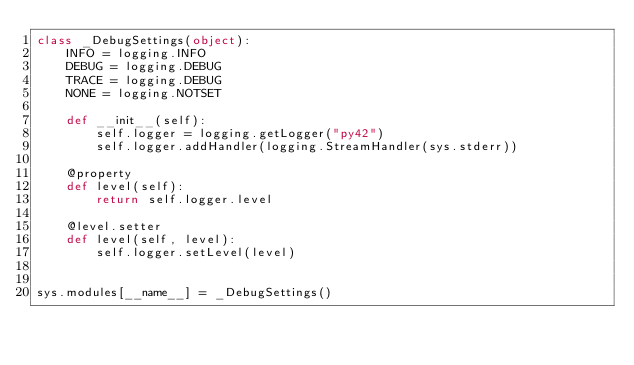Convert code to text. <code><loc_0><loc_0><loc_500><loc_500><_Python_>class _DebugSettings(object):
    INFO = logging.INFO
    DEBUG = logging.DEBUG
    TRACE = logging.DEBUG
    NONE = logging.NOTSET

    def __init__(self):
        self.logger = logging.getLogger("py42")
        self.logger.addHandler(logging.StreamHandler(sys.stderr))

    @property
    def level(self):
        return self.logger.level

    @level.setter
    def level(self, level):
        self.logger.setLevel(level)


sys.modules[__name__] = _DebugSettings()
</code> 